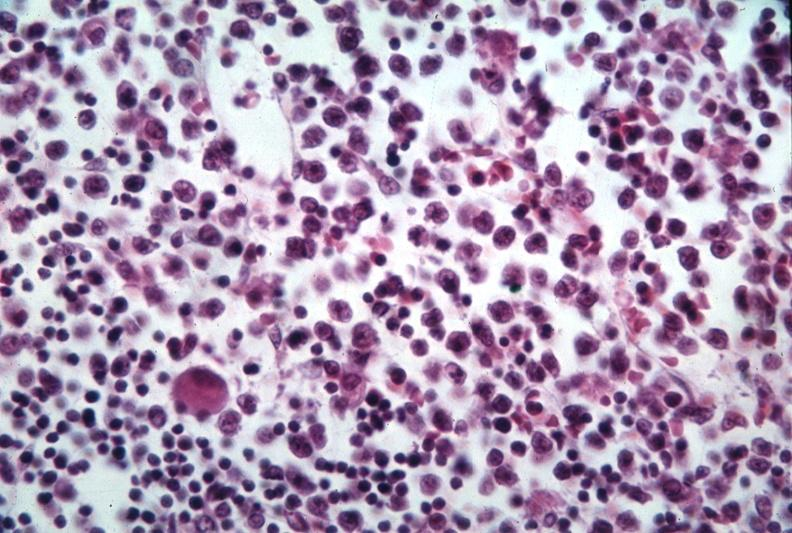s lymphoblastic lymphoma present?
Answer the question using a single word or phrase. Yes 